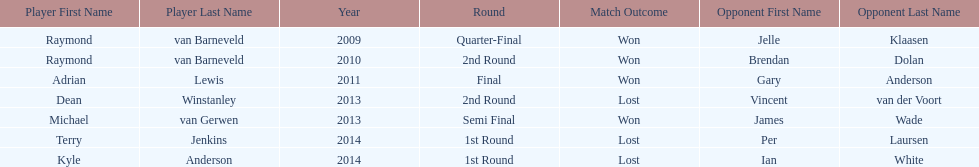Who was the last to win against his opponent? Michael van Gerwen. 